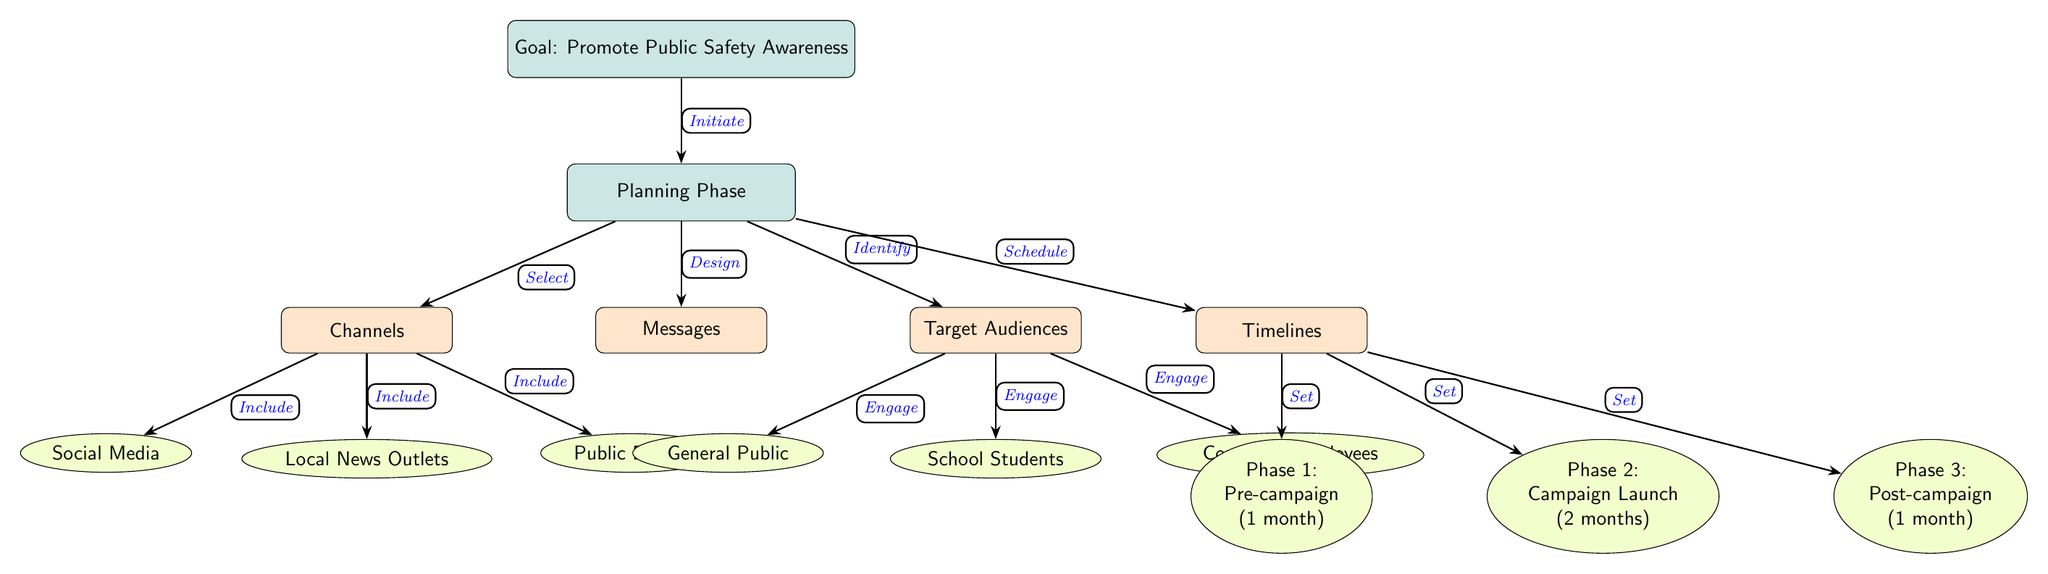What is the main goal of the campaign? The main goal of the campaign is explicitly stated in the top node of the diagram, which is to "Promote Public Safety Awareness." This is the overarching aim driving all the planning components illustrated.
Answer: Promote Public Safety Awareness How many target audiences are identified in the diagram? The diagram lists three distinct target audiences under the "Target Audiences" subnode: General Public, School Students, and Corporate Employees. To find the total, we simply count these options provided.
Answer: 3 What is the timeline for Phase 2 of the campaign? Looking at the timelines subnode, Phase 2 is labeled as "Campaign Launch" and specified to last two months. This is a direct identification from the data presented in the diagram.
Answer: 2 months Which channel includes social media? In the "Channels" subnode, social media is specifically listed as one of the included channels. This is a straightforward fact retrieved from the diagram's structure and labeling.
Answer: Social Media What action is associated with identifying target audiences? The diagram illustrates the action related to identifying target audiences as "Engage," which is shown as a connecting edge from "Target Audiences" to the audiences listed. This indicates the intent to actively involve these groups in the campaign.
Answer: Engage What are the components of the planning phase? The planning phase includes four components: Channels, Messages, Target Audiences, and Timelines. By examining the nodes connected to the "Planning Phase," we identify these specific areas of focus.
Answer: Channels, Messages, Target Audiences, Timelines What is the duration of the post-campaign phase? The "Post-campaign" phase is indicated as lasting one month in the timelines subnode. To find the duration, we reference the label directly in the diagram.
Answer: 1 month Which action is associated with the goal of the campaign? The action associated with the goal of promoting public safety awareness is labeled as "Initiate," which connects the goal node to the planning phase. This signifies the initial step in pursuing the identified campaign aim.
Answer: Initiate 